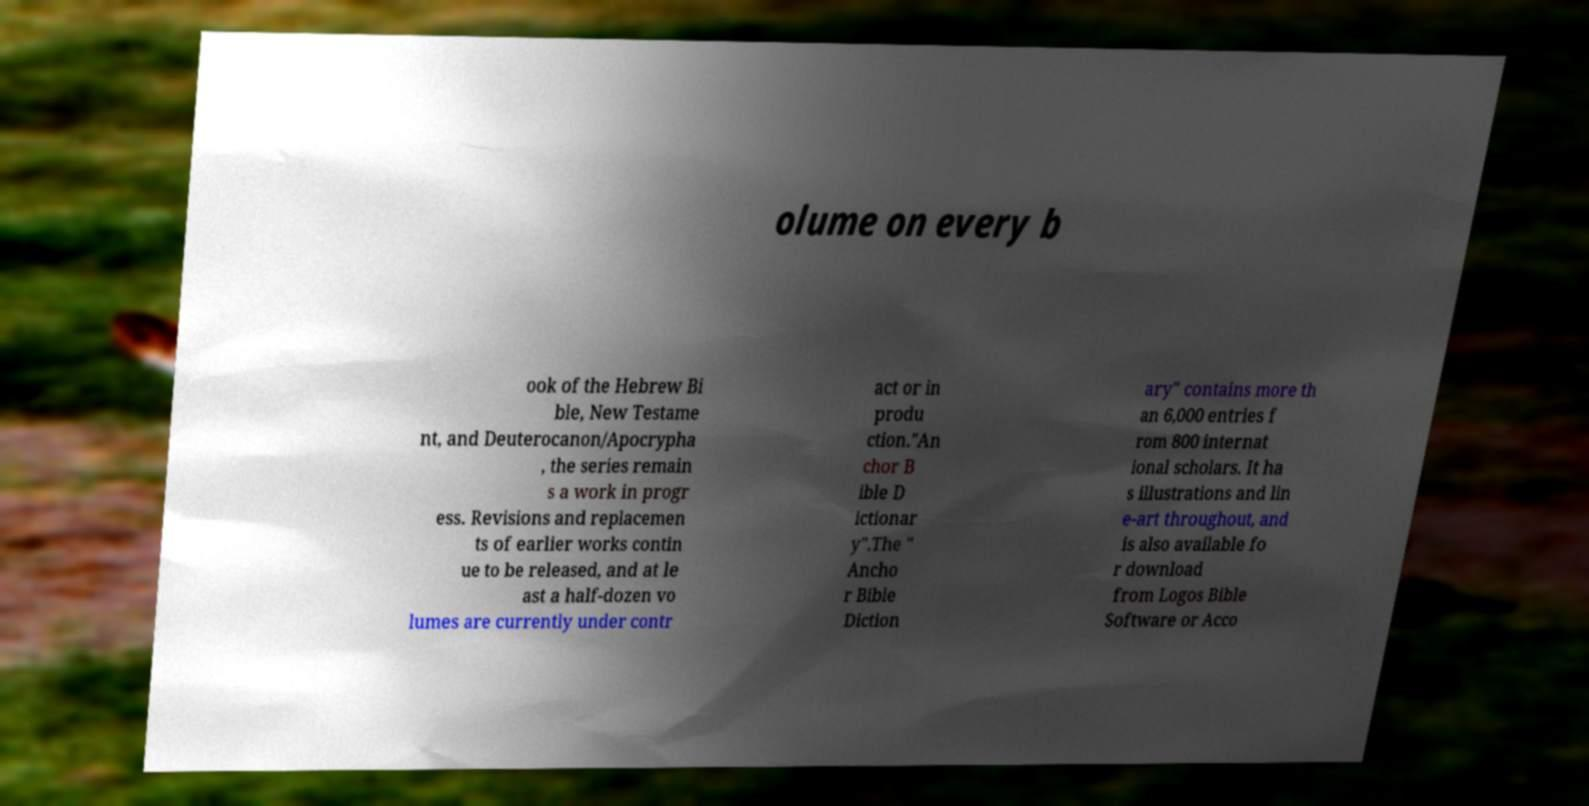Can you read and provide the text displayed in the image?This photo seems to have some interesting text. Can you extract and type it out for me? olume on every b ook of the Hebrew Bi ble, New Testame nt, and Deuterocanon/Apocrypha , the series remain s a work in progr ess. Revisions and replacemen ts of earlier works contin ue to be released, and at le ast a half-dozen vo lumes are currently under contr act or in produ ction."An chor B ible D ictionar y".The " Ancho r Bible Diction ary" contains more th an 6,000 entries f rom 800 internat ional scholars. It ha s illustrations and lin e-art throughout, and is also available fo r download from Logos Bible Software or Acco 